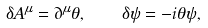Convert formula to latex. <formula><loc_0><loc_0><loc_500><loc_500>\delta A ^ { \mu } = \partial ^ { \mu } \theta , \quad \delta \psi = - i \theta \psi ,</formula> 